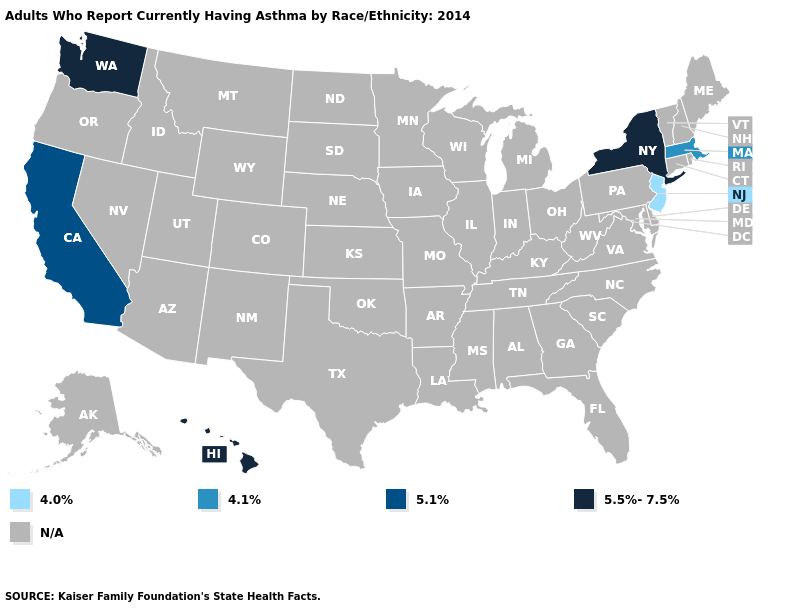Is the legend a continuous bar?
Keep it brief. No. Name the states that have a value in the range 5.5%-7.5%?
Keep it brief. Hawaii, New York, Washington. How many symbols are there in the legend?
Be succinct. 5. Name the states that have a value in the range N/A?
Keep it brief. Alabama, Alaska, Arizona, Arkansas, Colorado, Connecticut, Delaware, Florida, Georgia, Idaho, Illinois, Indiana, Iowa, Kansas, Kentucky, Louisiana, Maine, Maryland, Michigan, Minnesota, Mississippi, Missouri, Montana, Nebraska, Nevada, New Hampshire, New Mexico, North Carolina, North Dakota, Ohio, Oklahoma, Oregon, Pennsylvania, Rhode Island, South Carolina, South Dakota, Tennessee, Texas, Utah, Vermont, Virginia, West Virginia, Wisconsin, Wyoming. Name the states that have a value in the range 5.1%?
Concise answer only. California. What is the value of Wisconsin?
Quick response, please. N/A. Name the states that have a value in the range 4.1%?
Concise answer only. Massachusetts. Does Washington have the highest value in the West?
Short answer required. Yes. What is the value of Minnesota?
Give a very brief answer. N/A. Does Washington have the highest value in the USA?
Short answer required. Yes. What is the lowest value in the USA?
Answer briefly. 4.0%. 